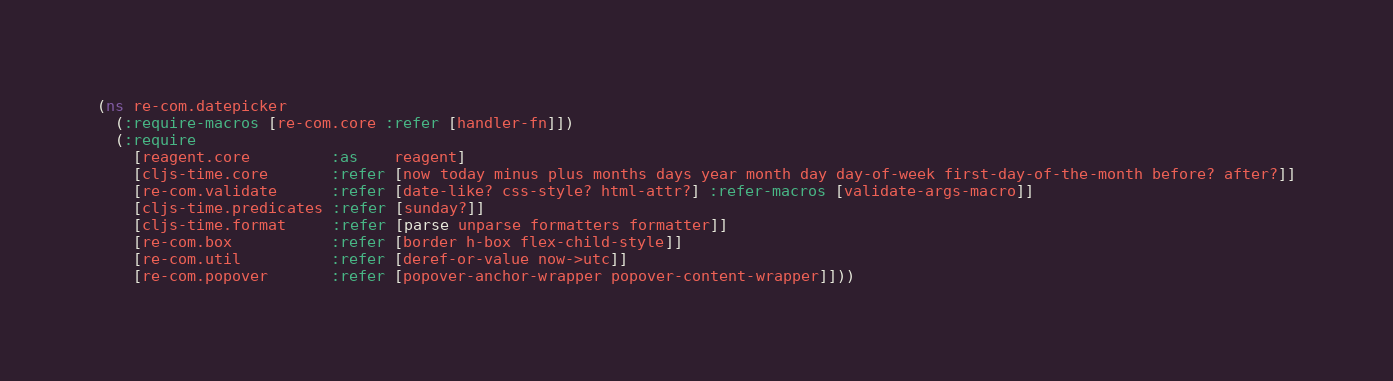Convert code to text. <code><loc_0><loc_0><loc_500><loc_500><_Clojure_>(ns re-com.datepicker
  (:require-macros [re-com.core :refer [handler-fn]])
  (:require
    [reagent.core         :as    reagent]
    [cljs-time.core       :refer [now today minus plus months days year month day day-of-week first-day-of-the-month before? after?]]
    [re-com.validate      :refer [date-like? css-style? html-attr?] :refer-macros [validate-args-macro]]
    [cljs-time.predicates :refer [sunday?]]
    [cljs-time.format     :refer [parse unparse formatters formatter]]
    [re-com.box           :refer [border h-box flex-child-style]]
    [re-com.util          :refer [deref-or-value now->utc]]
    [re-com.popover       :refer [popover-anchor-wrapper popover-content-wrapper]]))
</code> 